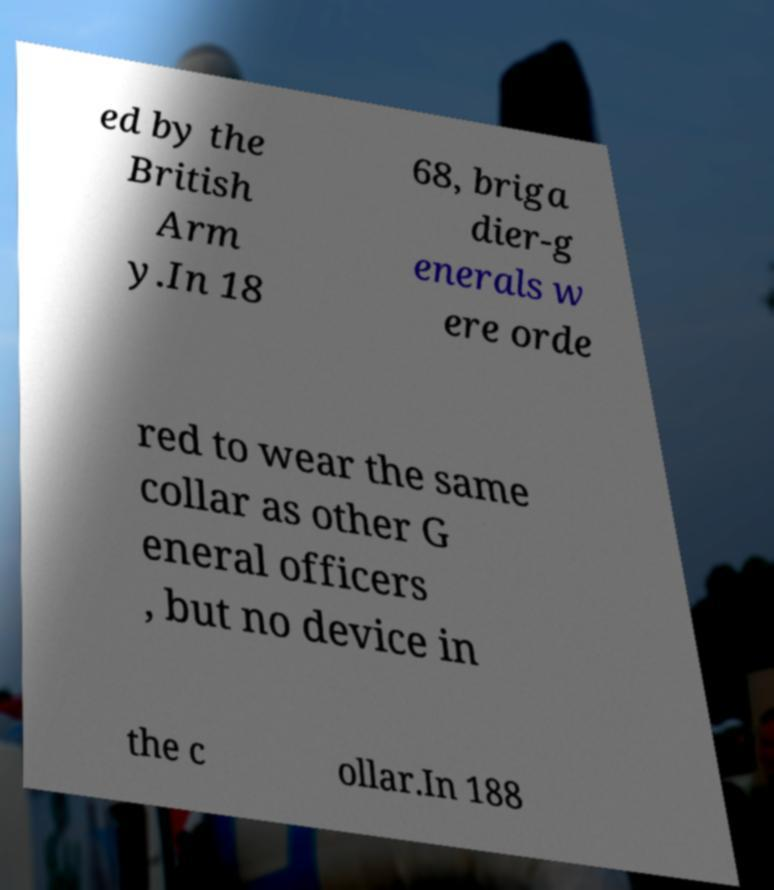For documentation purposes, I need the text within this image transcribed. Could you provide that? ed by the British Arm y.In 18 68, briga dier-g enerals w ere orde red to wear the same collar as other G eneral officers , but no device in the c ollar.In 188 